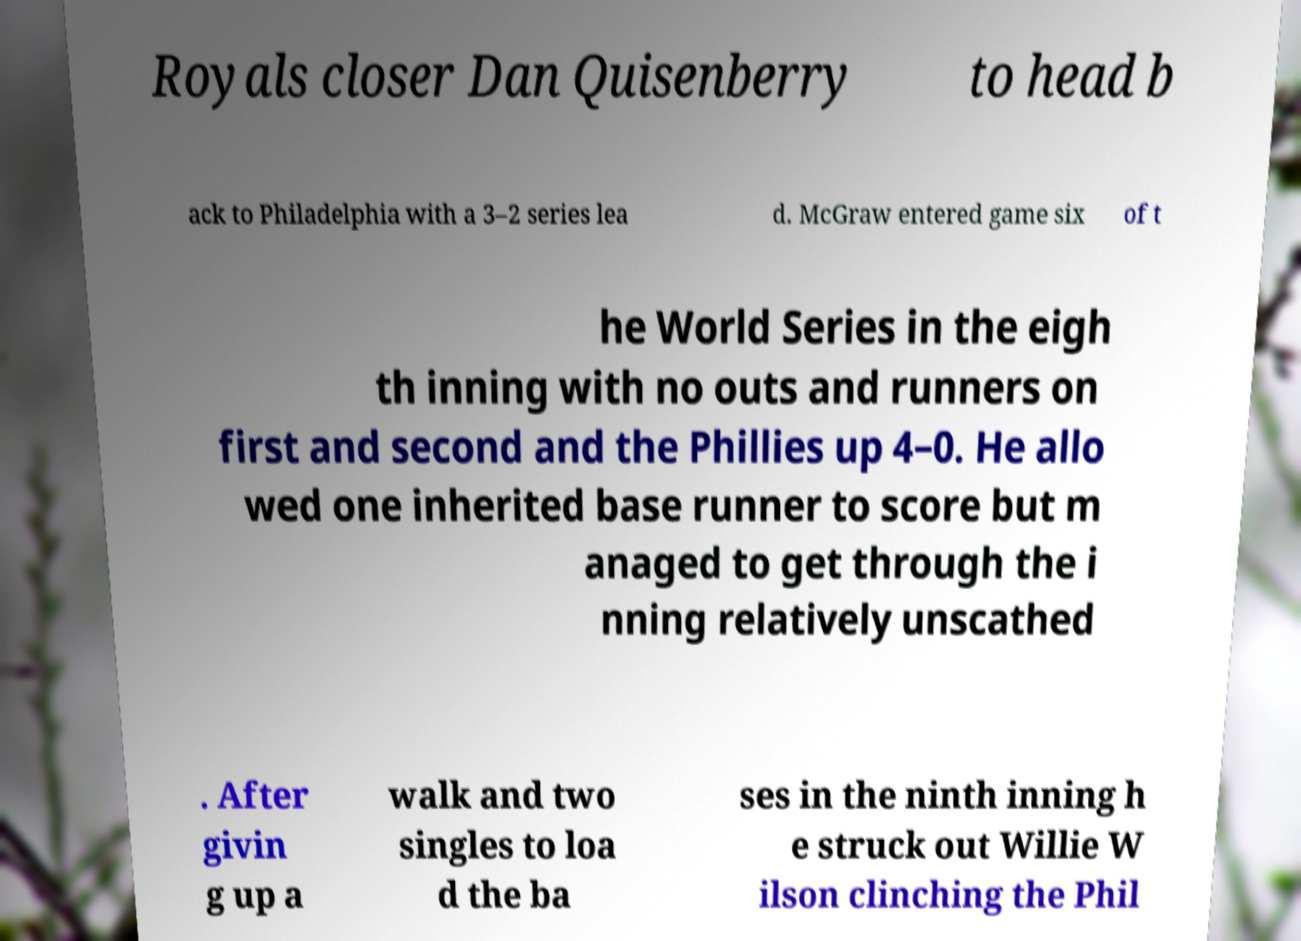Please read and relay the text visible in this image. What does it say? Royals closer Dan Quisenberry to head b ack to Philadelphia with a 3–2 series lea d. McGraw entered game six of t he World Series in the eigh th inning with no outs and runners on first and second and the Phillies up 4–0. He allo wed one inherited base runner to score but m anaged to get through the i nning relatively unscathed . After givin g up a walk and two singles to loa d the ba ses in the ninth inning h e struck out Willie W ilson clinching the Phil 